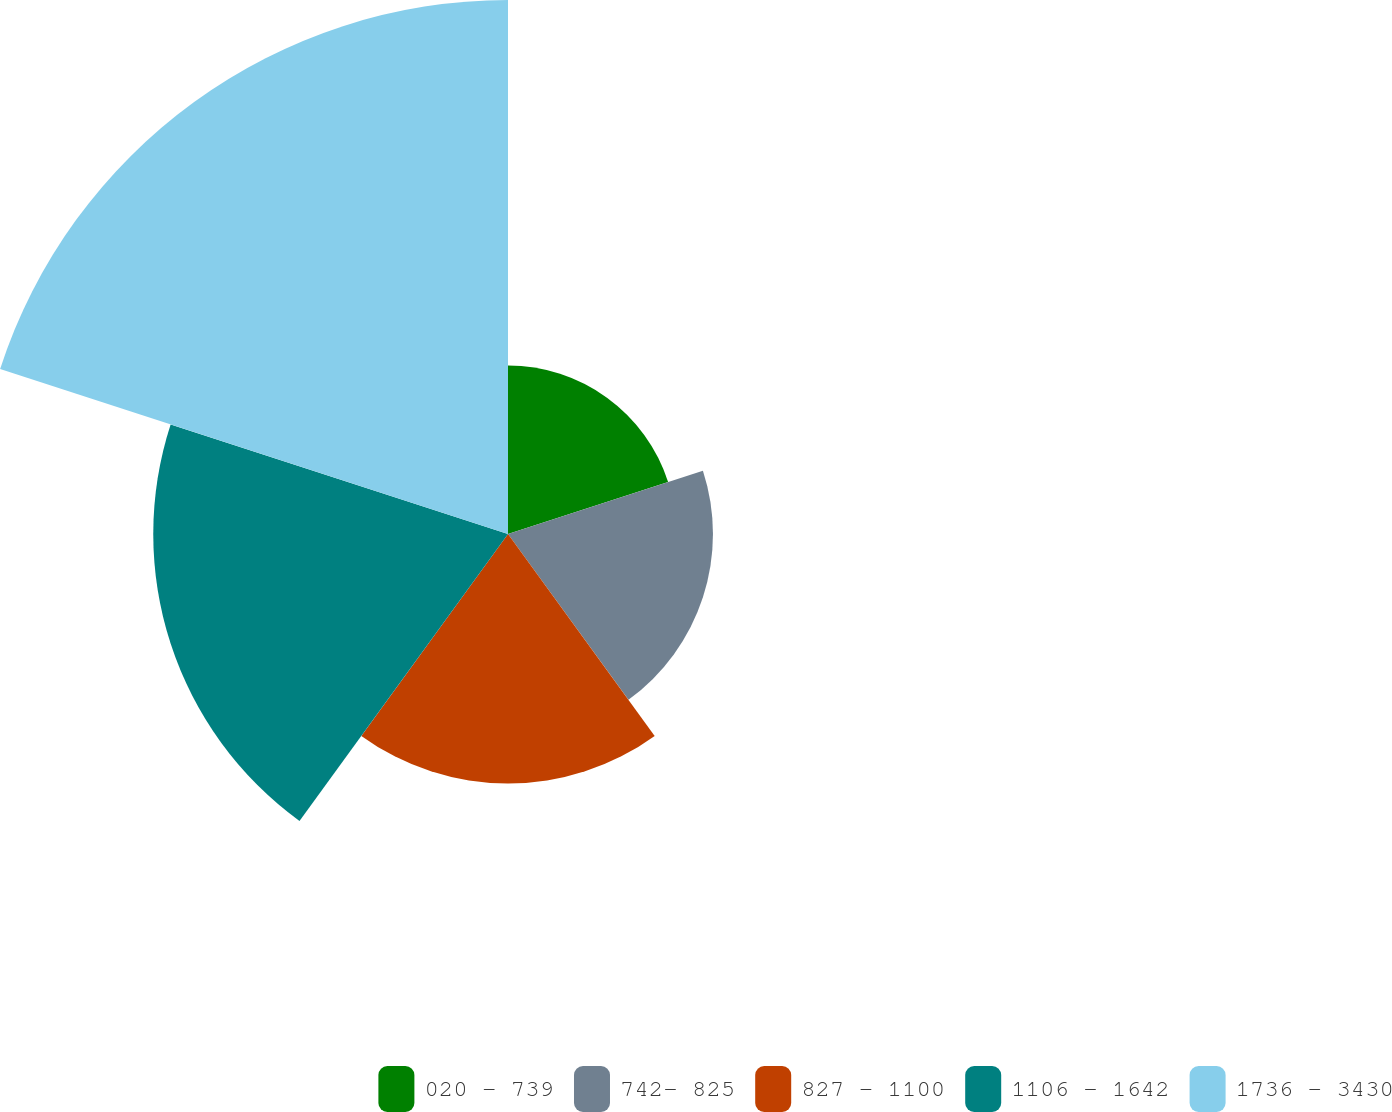<chart> <loc_0><loc_0><loc_500><loc_500><pie_chart><fcel>020 - 739<fcel>742- 825<fcel>827 - 1100<fcel>1106 - 1642<fcel>1736 - 3430<nl><fcel>11.14%<fcel>13.56%<fcel>16.51%<fcel>23.47%<fcel>35.33%<nl></chart> 